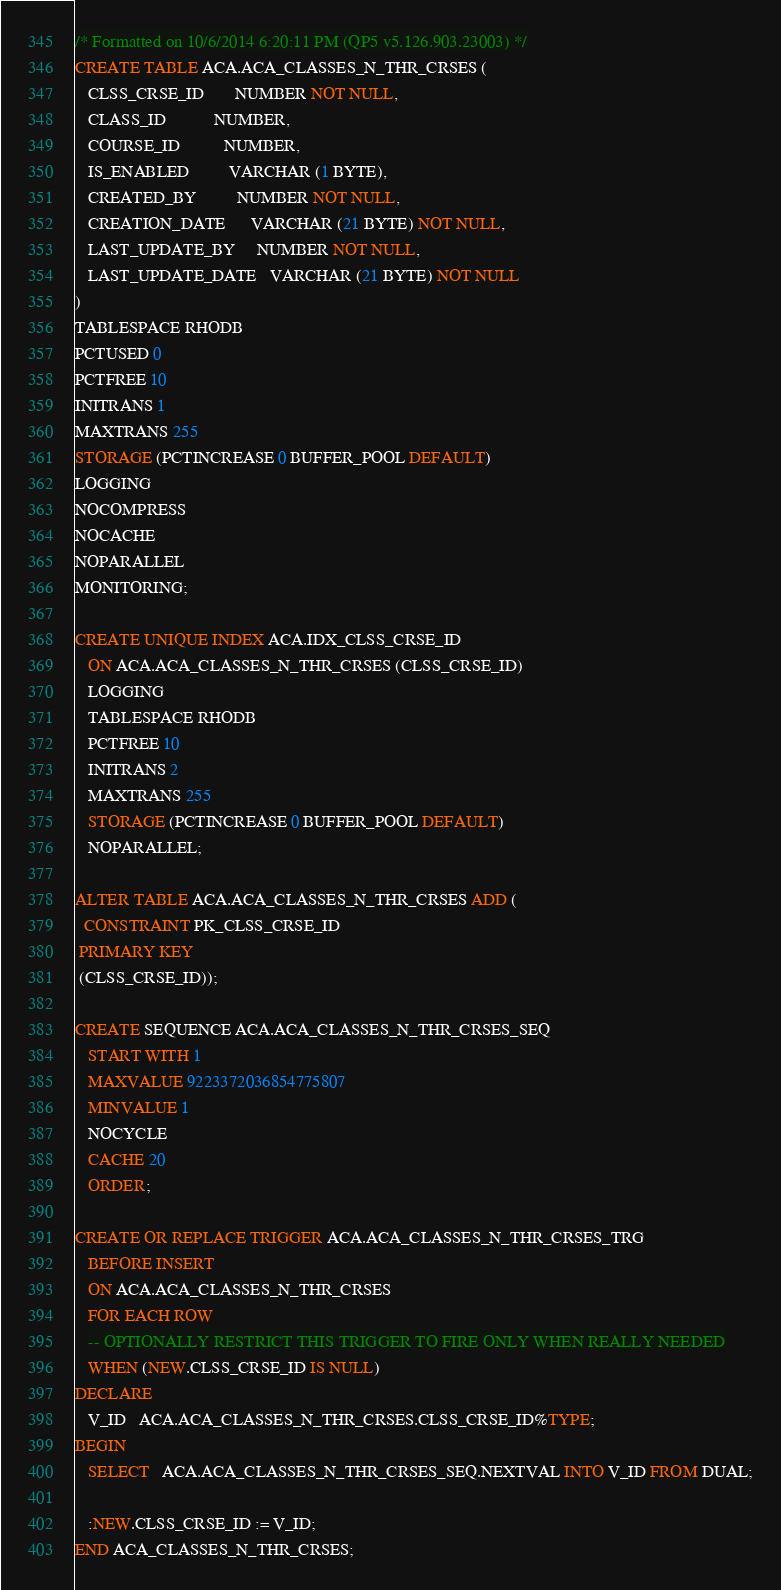<code> <loc_0><loc_0><loc_500><loc_500><_SQL_>/* Formatted on 10/6/2014 6:20:11 PM (QP5 v5.126.903.23003) */
CREATE TABLE ACA.ACA_CLASSES_N_THR_CRSES (
   CLSS_CRSE_ID       NUMBER NOT NULL,
   CLASS_ID           NUMBER,
   COURSE_ID          NUMBER,
   IS_ENABLED         VARCHAR (1 BYTE),
   CREATED_BY         NUMBER NOT NULL,
   CREATION_DATE      VARCHAR (21 BYTE) NOT NULL,
   LAST_UPDATE_BY     NUMBER NOT NULL,
   LAST_UPDATE_DATE   VARCHAR (21 BYTE) NOT NULL
)
TABLESPACE RHODB
PCTUSED 0
PCTFREE 10
INITRANS 1
MAXTRANS 255
STORAGE (PCTINCREASE 0 BUFFER_POOL DEFAULT)
LOGGING
NOCOMPRESS
NOCACHE
NOPARALLEL
MONITORING;

CREATE UNIQUE INDEX ACA.IDX_CLSS_CRSE_ID
   ON ACA.ACA_CLASSES_N_THR_CRSES (CLSS_CRSE_ID)
   LOGGING
   TABLESPACE RHODB
   PCTFREE 10
   INITRANS 2
   MAXTRANS 255
   STORAGE (PCTINCREASE 0 BUFFER_POOL DEFAULT)
   NOPARALLEL;

ALTER TABLE ACA.ACA_CLASSES_N_THR_CRSES ADD (
  CONSTRAINT PK_CLSS_CRSE_ID
 PRIMARY KEY
 (CLSS_CRSE_ID));

CREATE SEQUENCE ACA.ACA_CLASSES_N_THR_CRSES_SEQ
   START WITH 1
   MAXVALUE 9223372036854775807
   MINVALUE 1
   NOCYCLE
   CACHE 20
   ORDER;

CREATE OR REPLACE TRIGGER ACA.ACA_CLASSES_N_THR_CRSES_TRG
   BEFORE INSERT
   ON ACA.ACA_CLASSES_N_THR_CRSES
   FOR EACH ROW
   -- OPTIONALLY RESTRICT THIS TRIGGER TO FIRE ONLY WHEN REALLY NEEDED
   WHEN (NEW.CLSS_CRSE_ID IS NULL)
DECLARE
   V_ID   ACA.ACA_CLASSES_N_THR_CRSES.CLSS_CRSE_ID%TYPE;
BEGIN
   SELECT   ACA.ACA_CLASSES_N_THR_CRSES_SEQ.NEXTVAL INTO V_ID FROM DUAL;

   :NEW.CLSS_CRSE_ID := V_ID;
END ACA_CLASSES_N_THR_CRSES;</code> 